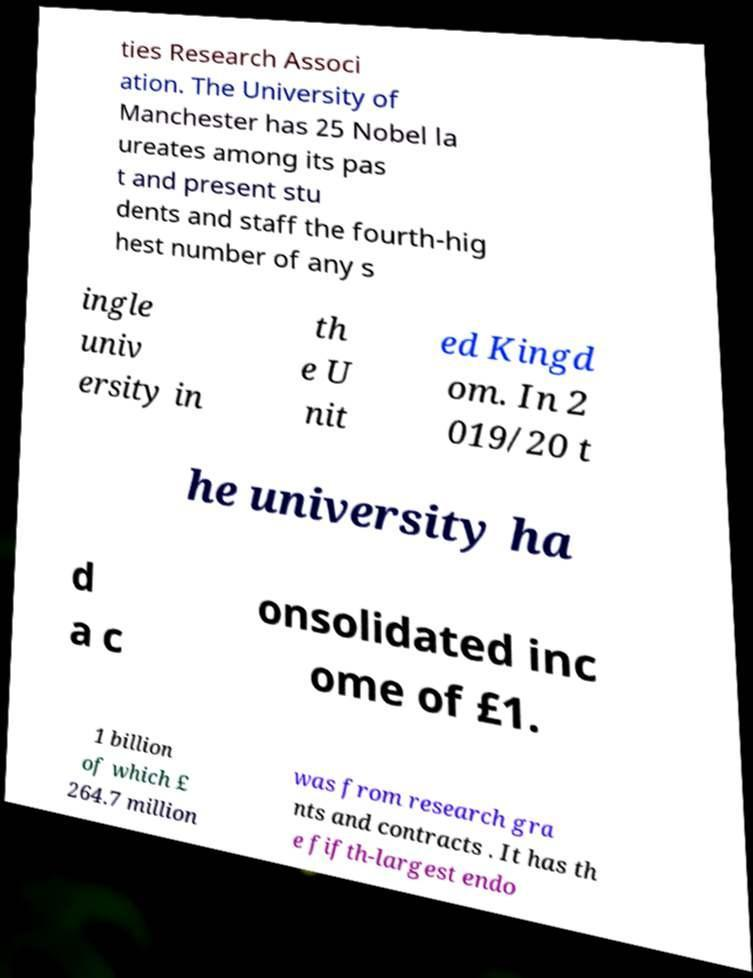Could you assist in decoding the text presented in this image and type it out clearly? ties Research Associ ation. The University of Manchester has 25 Nobel la ureates among its pas t and present stu dents and staff the fourth-hig hest number of any s ingle univ ersity in th e U nit ed Kingd om. In 2 019/20 t he university ha d a c onsolidated inc ome of £1. 1 billion of which £ 264.7 million was from research gra nts and contracts . It has th e fifth-largest endo 